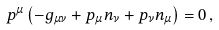<formula> <loc_0><loc_0><loc_500><loc_500>p ^ { \mu } \left ( - g _ { \mu \nu } + p _ { \mu } n _ { \nu } + p _ { \nu } n _ { \mu } \right ) = 0 \, ,</formula> 